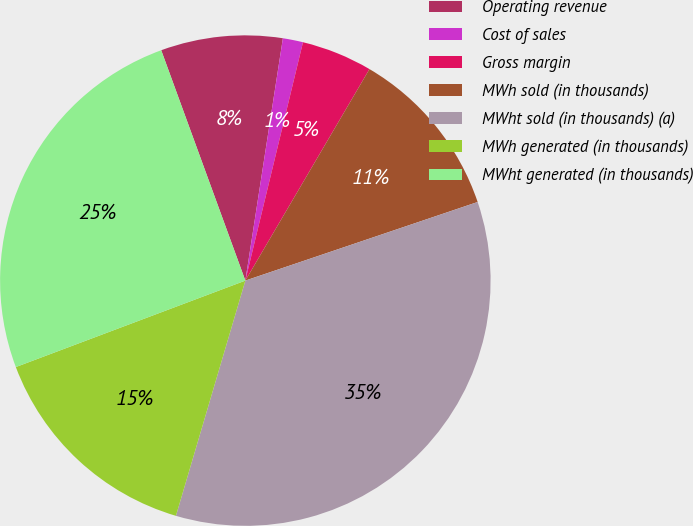<chart> <loc_0><loc_0><loc_500><loc_500><pie_chart><fcel>Operating revenue<fcel>Cost of sales<fcel>Gross margin<fcel>MWh sold (in thousands)<fcel>MWht sold (in thousands) (a)<fcel>MWh generated (in thousands)<fcel>MWht generated (in thousands)<nl><fcel>8.02%<fcel>1.33%<fcel>4.67%<fcel>11.36%<fcel>34.76%<fcel>14.7%<fcel>25.16%<nl></chart> 